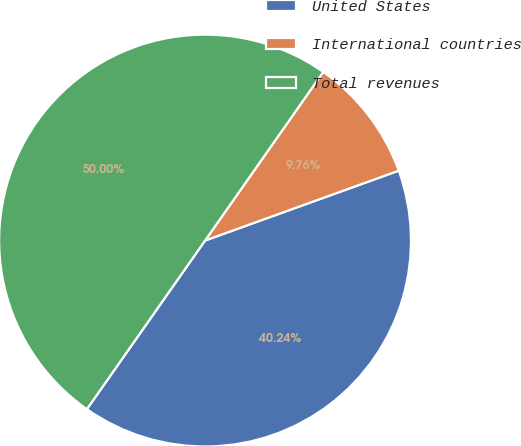Convert chart to OTSL. <chart><loc_0><loc_0><loc_500><loc_500><pie_chart><fcel>United States<fcel>International countries<fcel>Total revenues<nl><fcel>40.24%<fcel>9.76%<fcel>50.0%<nl></chart> 